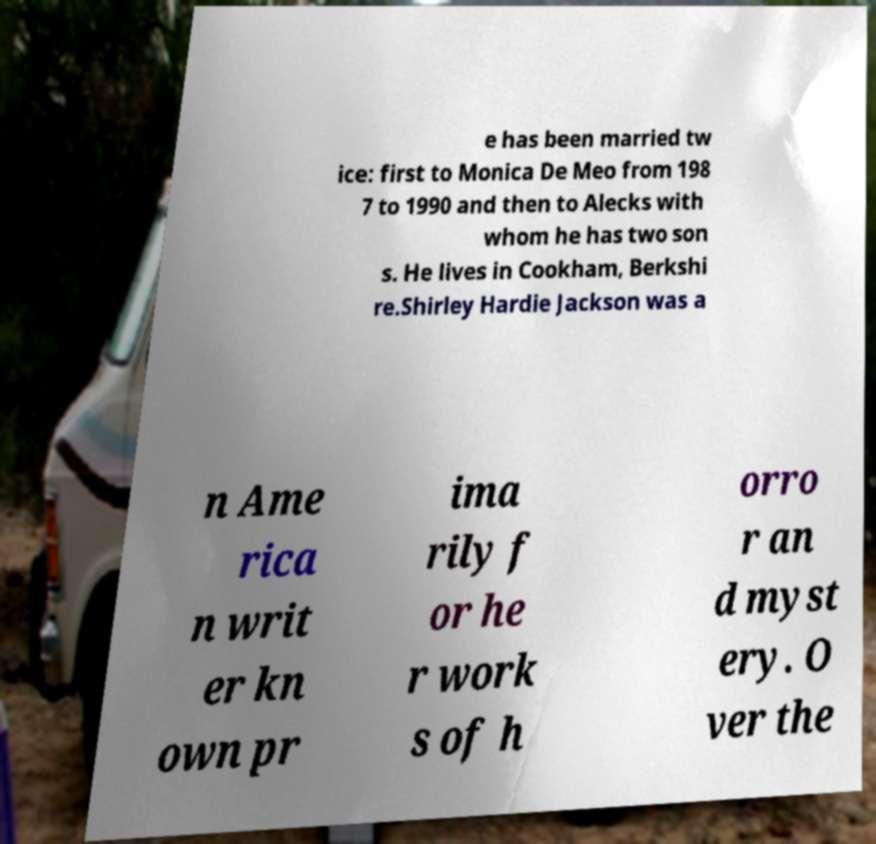Could you extract and type out the text from this image? e has been married tw ice: first to Monica De Meo from 198 7 to 1990 and then to Alecks with whom he has two son s. He lives in Cookham, Berkshi re.Shirley Hardie Jackson was a n Ame rica n writ er kn own pr ima rily f or he r work s of h orro r an d myst ery. O ver the 